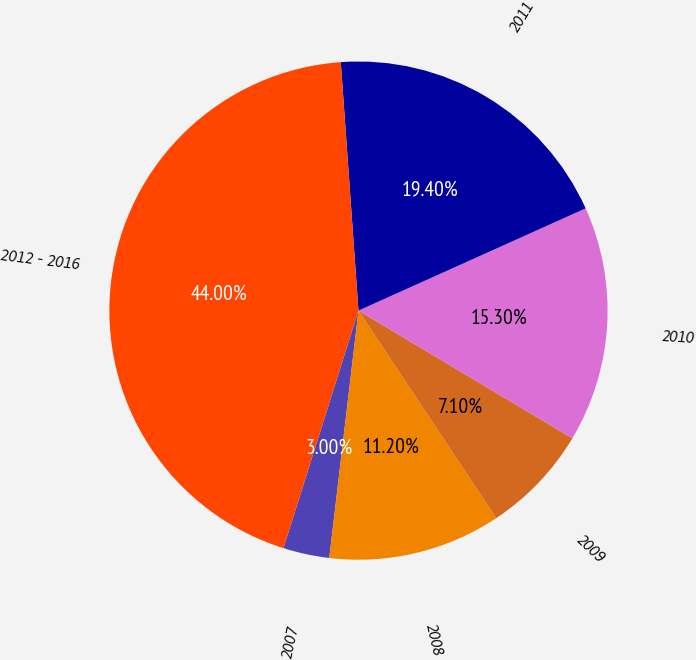Convert chart. <chart><loc_0><loc_0><loc_500><loc_500><pie_chart><fcel>2007<fcel>2008<fcel>2009<fcel>2010<fcel>2011<fcel>2012 - 2016<nl><fcel>3.0%<fcel>11.2%<fcel>7.1%<fcel>15.3%<fcel>19.4%<fcel>44.0%<nl></chart> 